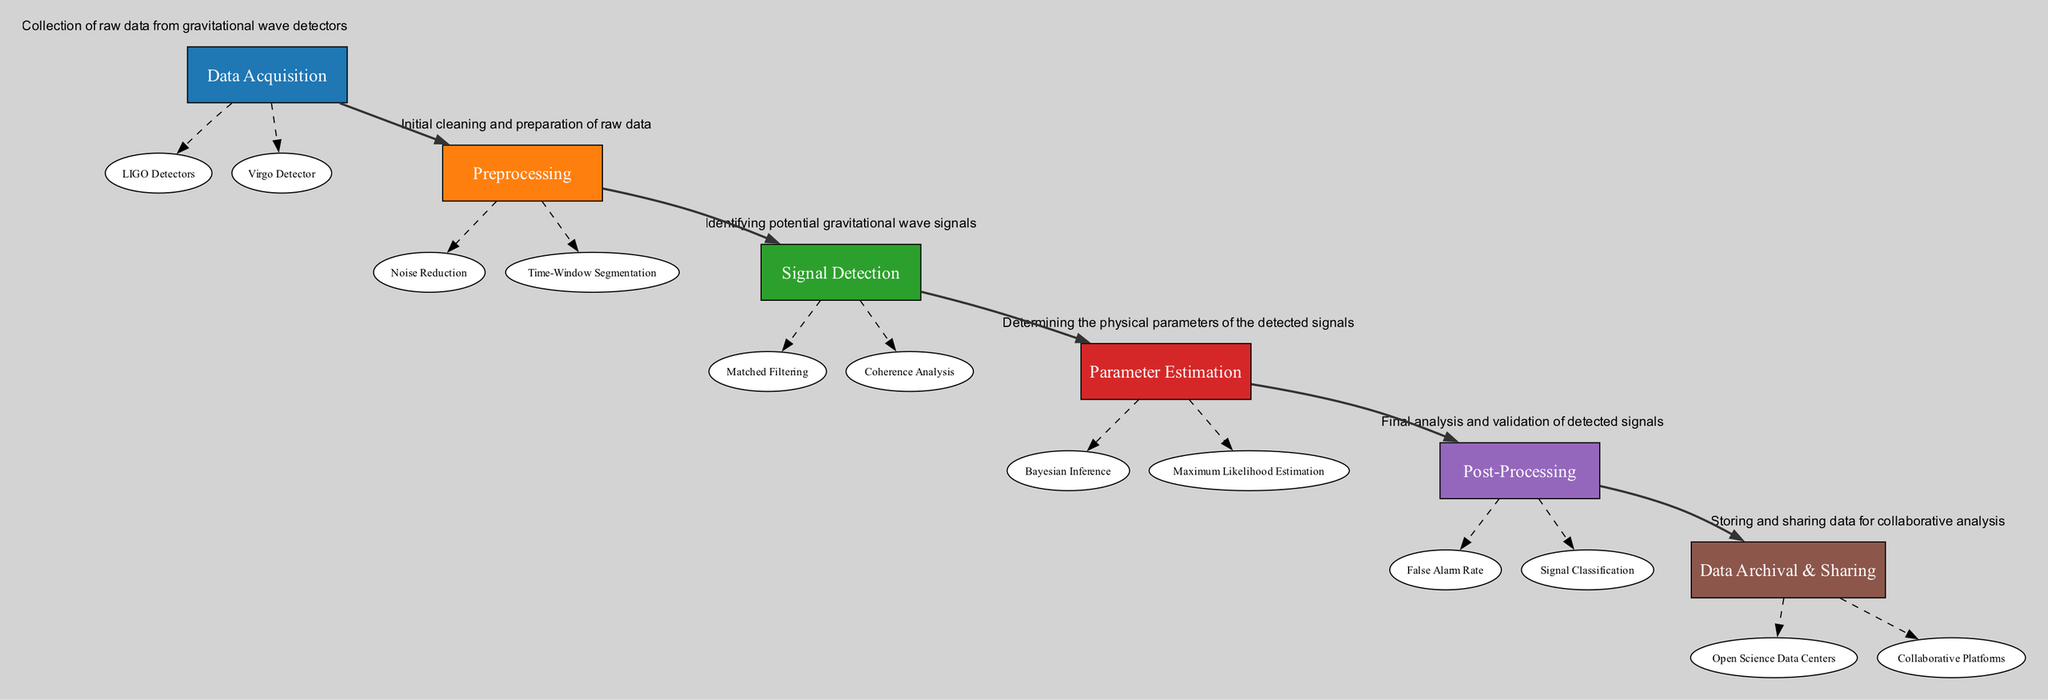What is the first step in the data analysis workflow? The first step in the diagram is "Data Acquisition," which is highlighted at the top of the workflow.
Answer: Data Acquisition How many main elements are present in the workflow? The diagram contains five main elements: Data Acquisition, Preprocessing, Signal Detection, Parameter Estimation, and Post-Processing.
Answer: Five What is the last step in the workflow? The last step, shown at the bottom of the workflow diagram, is "Data Archival & Sharing."
Answer: Data Archival & Sharing Which sub-element is related to filtering noise? The sub-element "Noise Reduction" under the "Preprocessing" element is specifically focused on filtering out environmental and instrumental noise.
Answer: Noise Reduction How do you identify potential gravitational wave signals? Potential gravitational wave signals are identified through the "Signal Detection" step, specifically using techniques such as "Matched Filtering" and "Coherence Analysis."
Answer: Signal Detection What is the outcome when using Maximum Likelihood Estimation? The outcome is an estimate of the parameters associated with the detected gravitational wave signals, which is part of the "Parameter Estimation" sub-process.
Answer: Estimated parameters What analysis is done to ensure signal reliability? The analysis performed to ensure signal reliability is "False Alarm Rate," which calculates the rate of false detections during post-processing.
Answer: False Alarm Rate Which element involves collaborative platforms for data sharing? The "Data Archival & Sharing" element includes "Collaborative Platforms," which facilitate sharing and storing of data for collaborative analysis.
Answer: Collaborative Platforms What corresponds to the filtering of data into manageable segments? "Time-Window Segmentation" under the "Preprocessing" element corresponds to the process of filtering data into manageable segments.
Answer: Time-Window Segmentation How does the workflow progress after Preprocessing? After "Preprocessing," the workflow progresses to "Signal Detection," which is indicated by a connection between these two elements in the diagram.
Answer: Signal Detection 